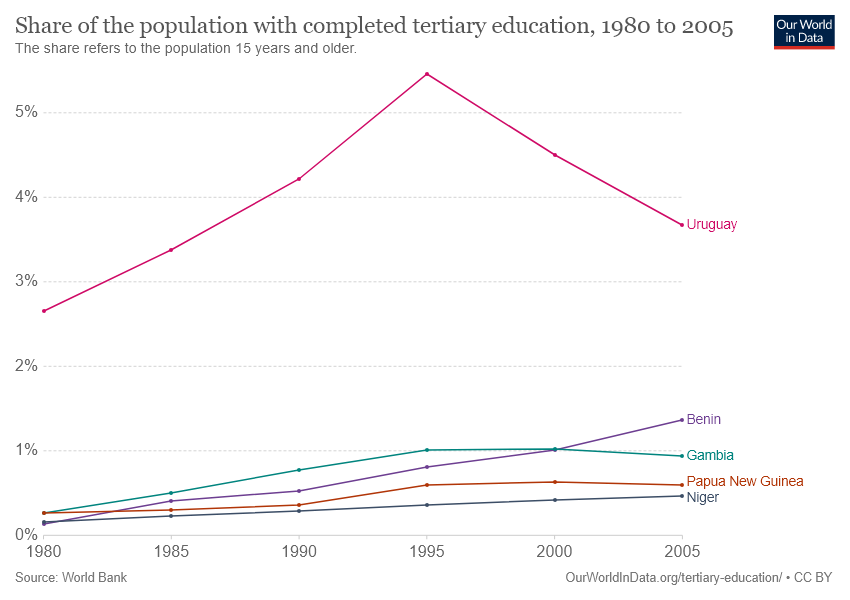Mention a couple of crucial points in this snapshot. The country represented by the red color line is Papua New Guinea. In 1995, the highest share of the population in Uruguay had attained tertiary education. 